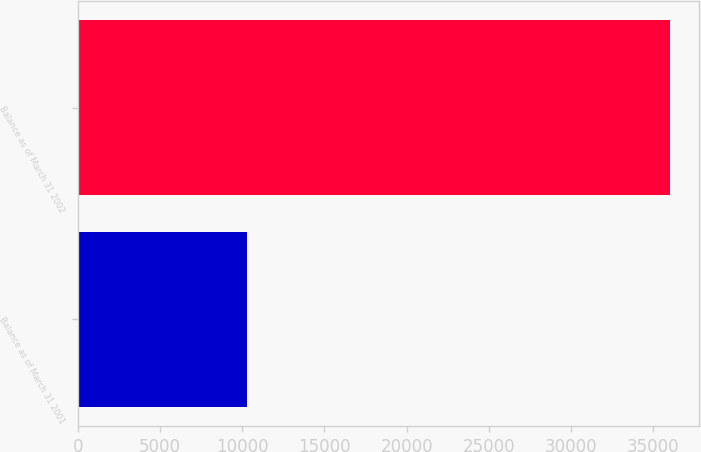Convert chart to OTSL. <chart><loc_0><loc_0><loc_500><loc_500><bar_chart><fcel>Balance as of March 31 2001<fcel>Balance as of March 31 2002<nl><fcel>10316<fcel>35992<nl></chart> 